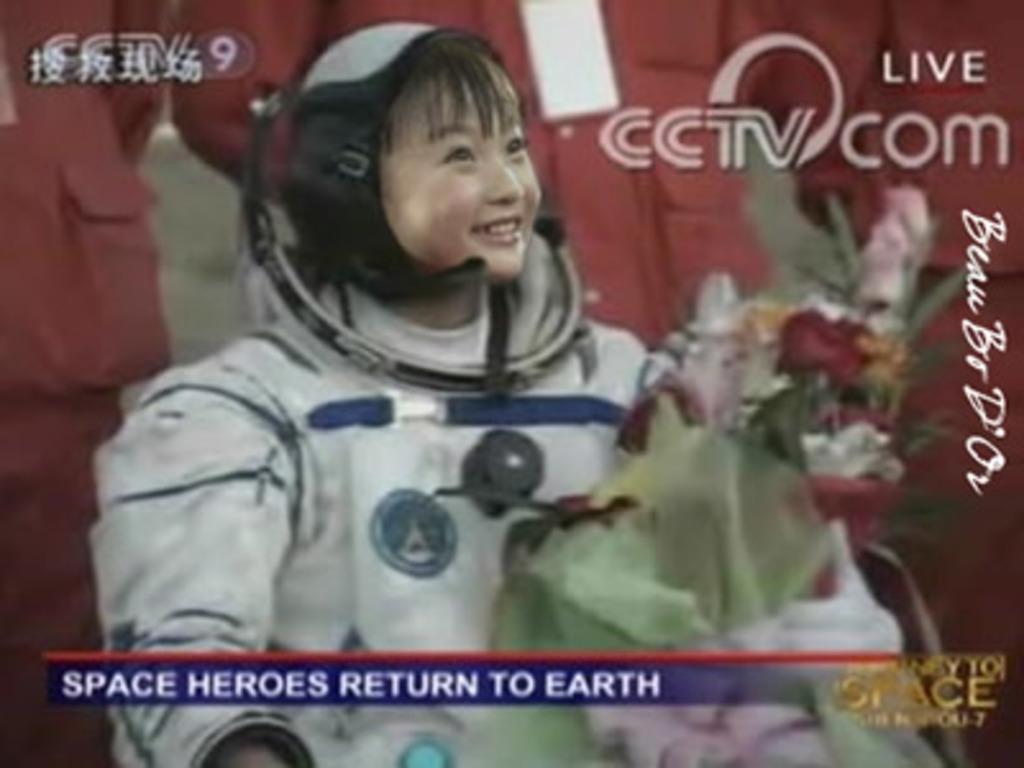Can you describe this image briefly? In this image, we can see a person wearing space jacket and there is a flower bouquet. 